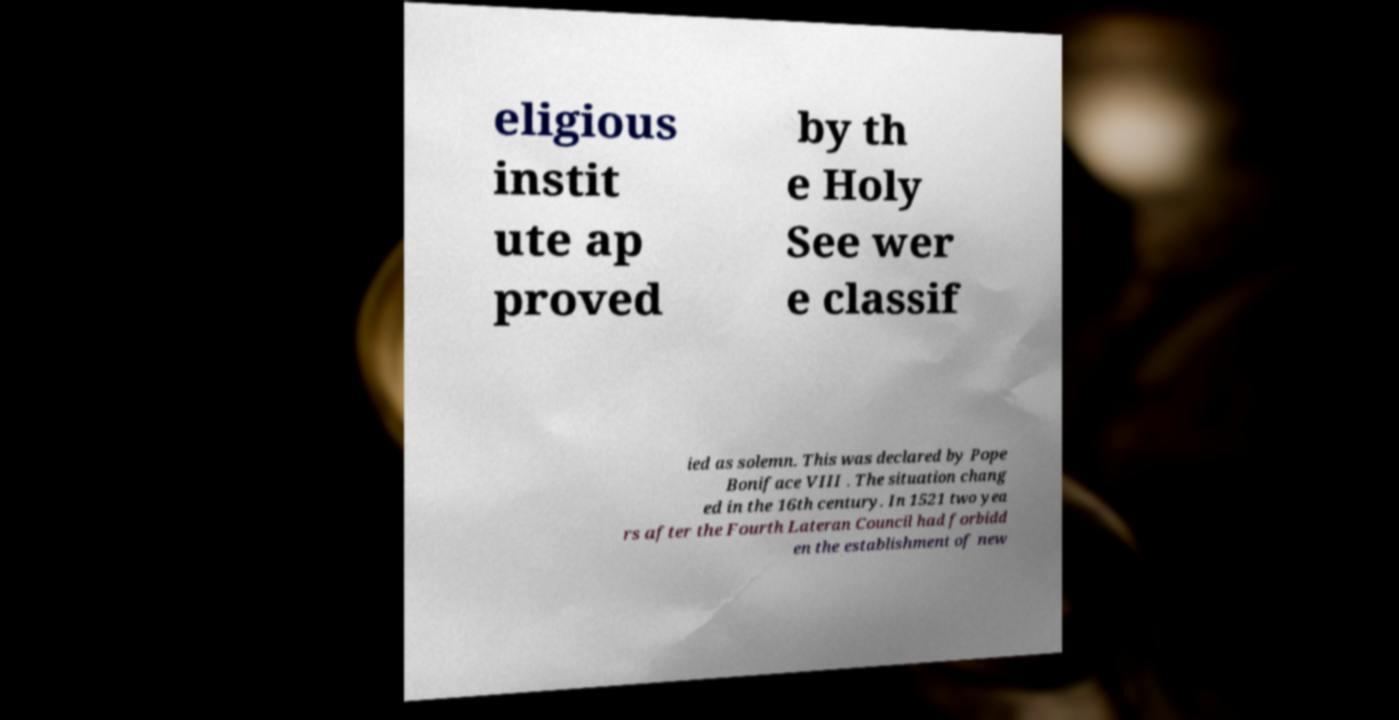Could you extract and type out the text from this image? eligious instit ute ap proved by th e Holy See wer e classif ied as solemn. This was declared by Pope Boniface VIII . The situation chang ed in the 16th century. In 1521 two yea rs after the Fourth Lateran Council had forbidd en the establishment of new 